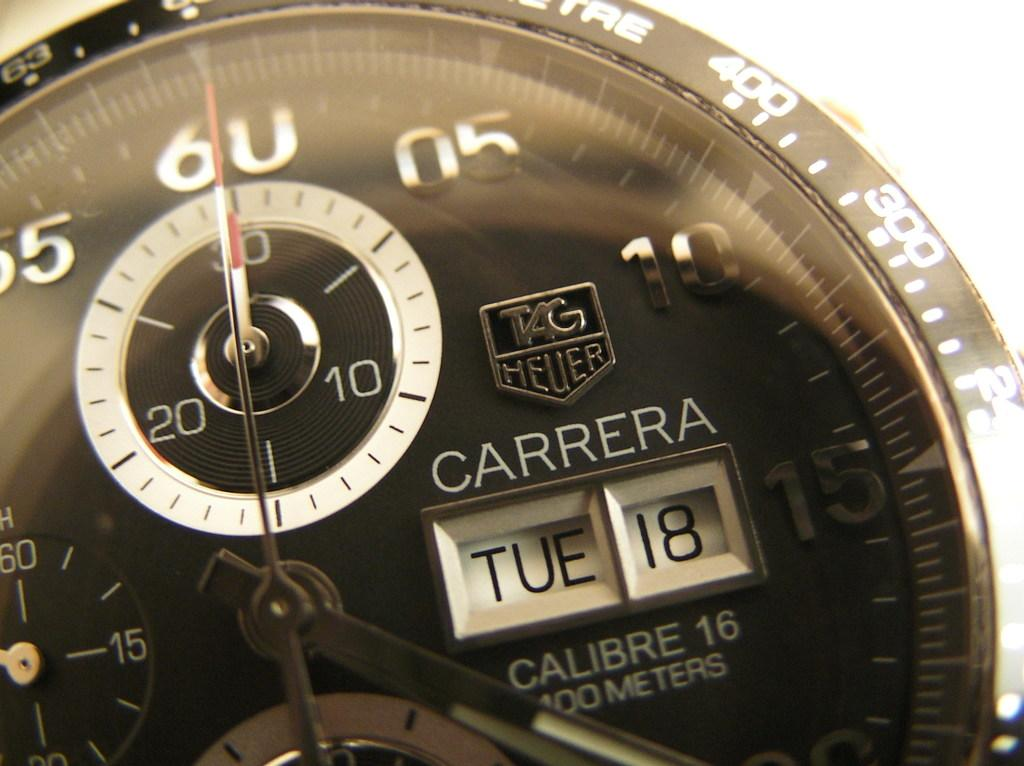<image>
Give a short and clear explanation of the subsequent image. A Carrera watch says that today is Tuesday the 18th. 